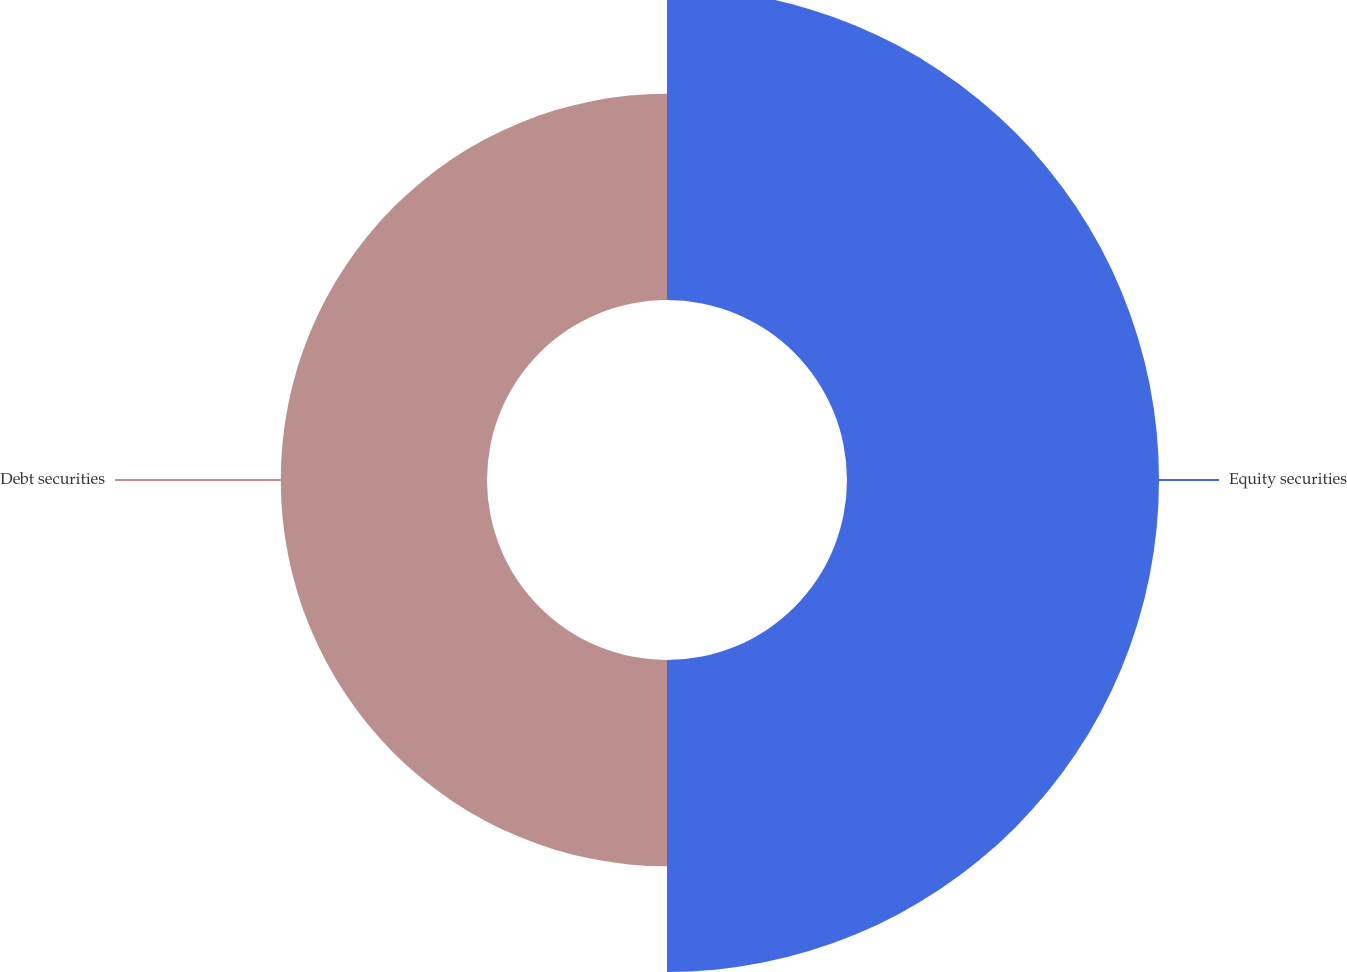Convert chart. <chart><loc_0><loc_0><loc_500><loc_500><pie_chart><fcel>Equity securities<fcel>Debt securities<nl><fcel>60.2%<fcel>39.8%<nl></chart> 